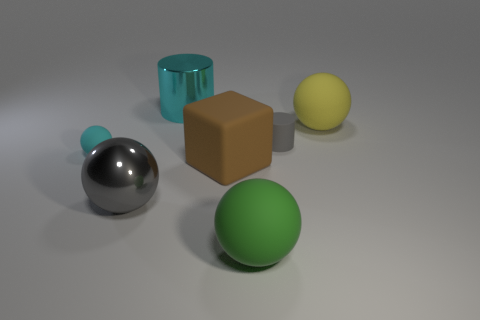Subtract all cyan rubber balls. How many balls are left? 3 Add 1 rubber cubes. How many objects exist? 8 Subtract all cyan cylinders. How many cylinders are left? 1 Subtract all blocks. How many objects are left? 6 Subtract all green spheres. Subtract all cyan blocks. How many spheres are left? 3 Subtract 0 red cylinders. How many objects are left? 7 Subtract all blue rubber cubes. Subtract all big yellow balls. How many objects are left? 6 Add 1 large yellow things. How many large yellow things are left? 2 Add 1 large yellow rubber things. How many large yellow rubber things exist? 2 